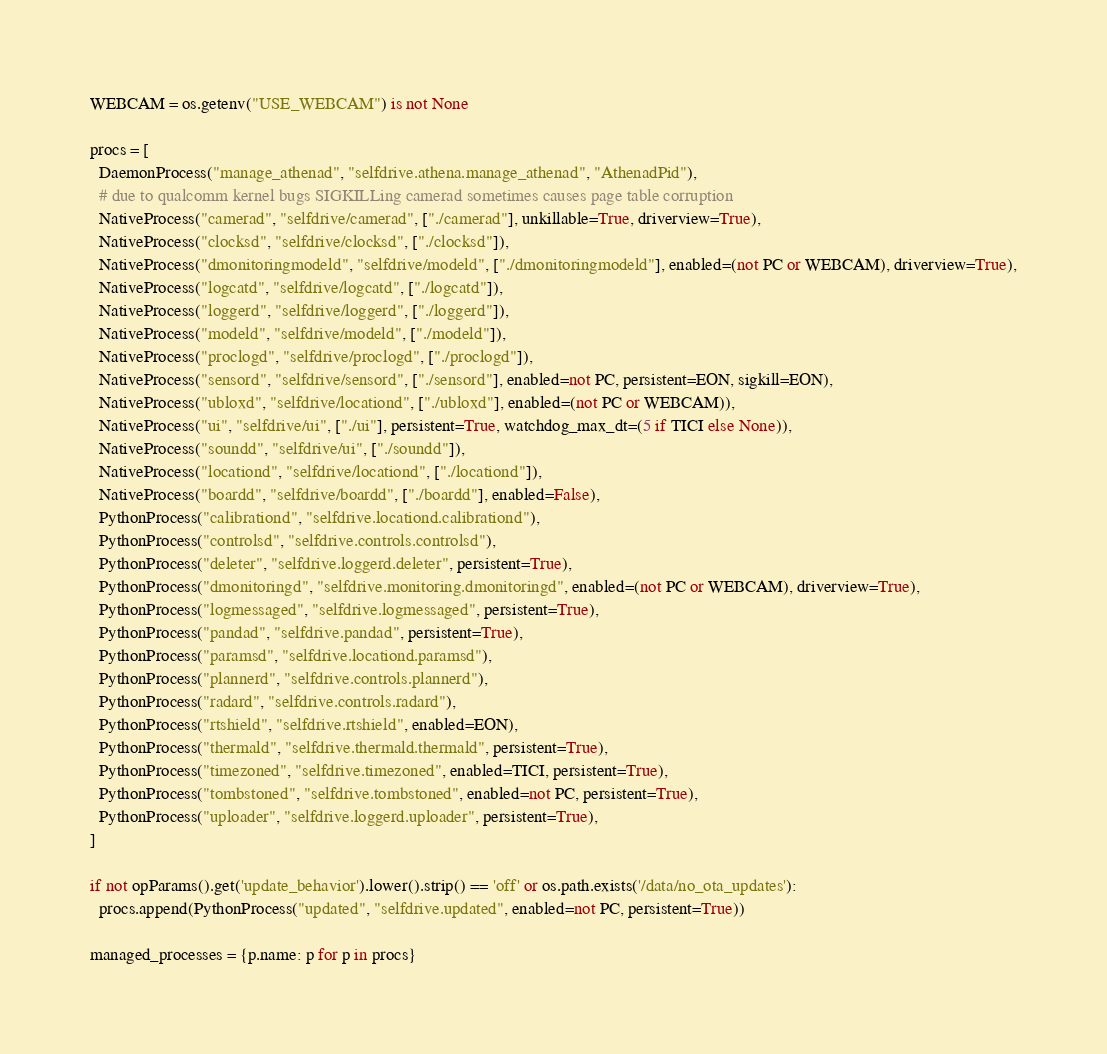Convert code to text. <code><loc_0><loc_0><loc_500><loc_500><_Python_>WEBCAM = os.getenv("USE_WEBCAM") is not None

procs = [
  DaemonProcess("manage_athenad", "selfdrive.athena.manage_athenad", "AthenadPid"),
  # due to qualcomm kernel bugs SIGKILLing camerad sometimes causes page table corruption
  NativeProcess("camerad", "selfdrive/camerad", ["./camerad"], unkillable=True, driverview=True),
  NativeProcess("clocksd", "selfdrive/clocksd", ["./clocksd"]),
  NativeProcess("dmonitoringmodeld", "selfdrive/modeld", ["./dmonitoringmodeld"], enabled=(not PC or WEBCAM), driverview=True),
  NativeProcess("logcatd", "selfdrive/logcatd", ["./logcatd"]),
  NativeProcess("loggerd", "selfdrive/loggerd", ["./loggerd"]),
  NativeProcess("modeld", "selfdrive/modeld", ["./modeld"]),
  NativeProcess("proclogd", "selfdrive/proclogd", ["./proclogd"]),
  NativeProcess("sensord", "selfdrive/sensord", ["./sensord"], enabled=not PC, persistent=EON, sigkill=EON),
  NativeProcess("ubloxd", "selfdrive/locationd", ["./ubloxd"], enabled=(not PC or WEBCAM)),
  NativeProcess("ui", "selfdrive/ui", ["./ui"], persistent=True, watchdog_max_dt=(5 if TICI else None)),
  NativeProcess("soundd", "selfdrive/ui", ["./soundd"]),
  NativeProcess("locationd", "selfdrive/locationd", ["./locationd"]),
  NativeProcess("boardd", "selfdrive/boardd", ["./boardd"], enabled=False),
  PythonProcess("calibrationd", "selfdrive.locationd.calibrationd"),
  PythonProcess("controlsd", "selfdrive.controls.controlsd"),
  PythonProcess("deleter", "selfdrive.loggerd.deleter", persistent=True),
  PythonProcess("dmonitoringd", "selfdrive.monitoring.dmonitoringd", enabled=(not PC or WEBCAM), driverview=True),
  PythonProcess("logmessaged", "selfdrive.logmessaged", persistent=True),
  PythonProcess("pandad", "selfdrive.pandad", persistent=True),
  PythonProcess("paramsd", "selfdrive.locationd.paramsd"),
  PythonProcess("plannerd", "selfdrive.controls.plannerd"),
  PythonProcess("radard", "selfdrive.controls.radard"),
  PythonProcess("rtshield", "selfdrive.rtshield", enabled=EON),
  PythonProcess("thermald", "selfdrive.thermald.thermald", persistent=True),
  PythonProcess("timezoned", "selfdrive.timezoned", enabled=TICI, persistent=True),
  PythonProcess("tombstoned", "selfdrive.tombstoned", enabled=not PC, persistent=True),
  PythonProcess("uploader", "selfdrive.loggerd.uploader", persistent=True),
]

if not opParams().get('update_behavior').lower().strip() == 'off' or os.path.exists('/data/no_ota_updates'):
  procs.append(PythonProcess("updated", "selfdrive.updated", enabled=not PC, persistent=True))

managed_processes = {p.name: p for p in procs}
</code> 